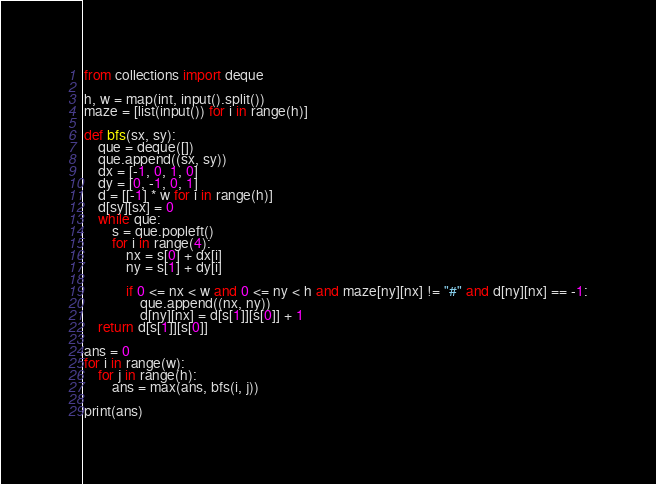<code> <loc_0><loc_0><loc_500><loc_500><_Python_>from collections import deque

h, w = map(int, input().split())
maze = [list(input()) for i in range(h)]

def bfs(sx, sy):
    que = deque([])
    que.append((sx, sy))
    dx = [-1, 0, 1, 0]
    dy = [0, -1, 0, 1]
    d = [[-1] * w for i in range(h)]
    d[sy][sx] = 0
    while que:
        s = que.popleft()
        for i in range(4):
            nx = s[0] + dx[i]
            ny = s[1] + dy[i]
            
            if 0 <= nx < w and 0 <= ny < h and maze[ny][nx] != "#" and d[ny][nx] == -1:
                que.append((nx, ny))
                d[ny][nx] = d[s[1]][s[0]] + 1
    return d[s[1]][s[0]]

ans = 0
for i in range(w):
    for j in range(h):
        ans = max(ans, bfs(i, j))

print(ans)</code> 